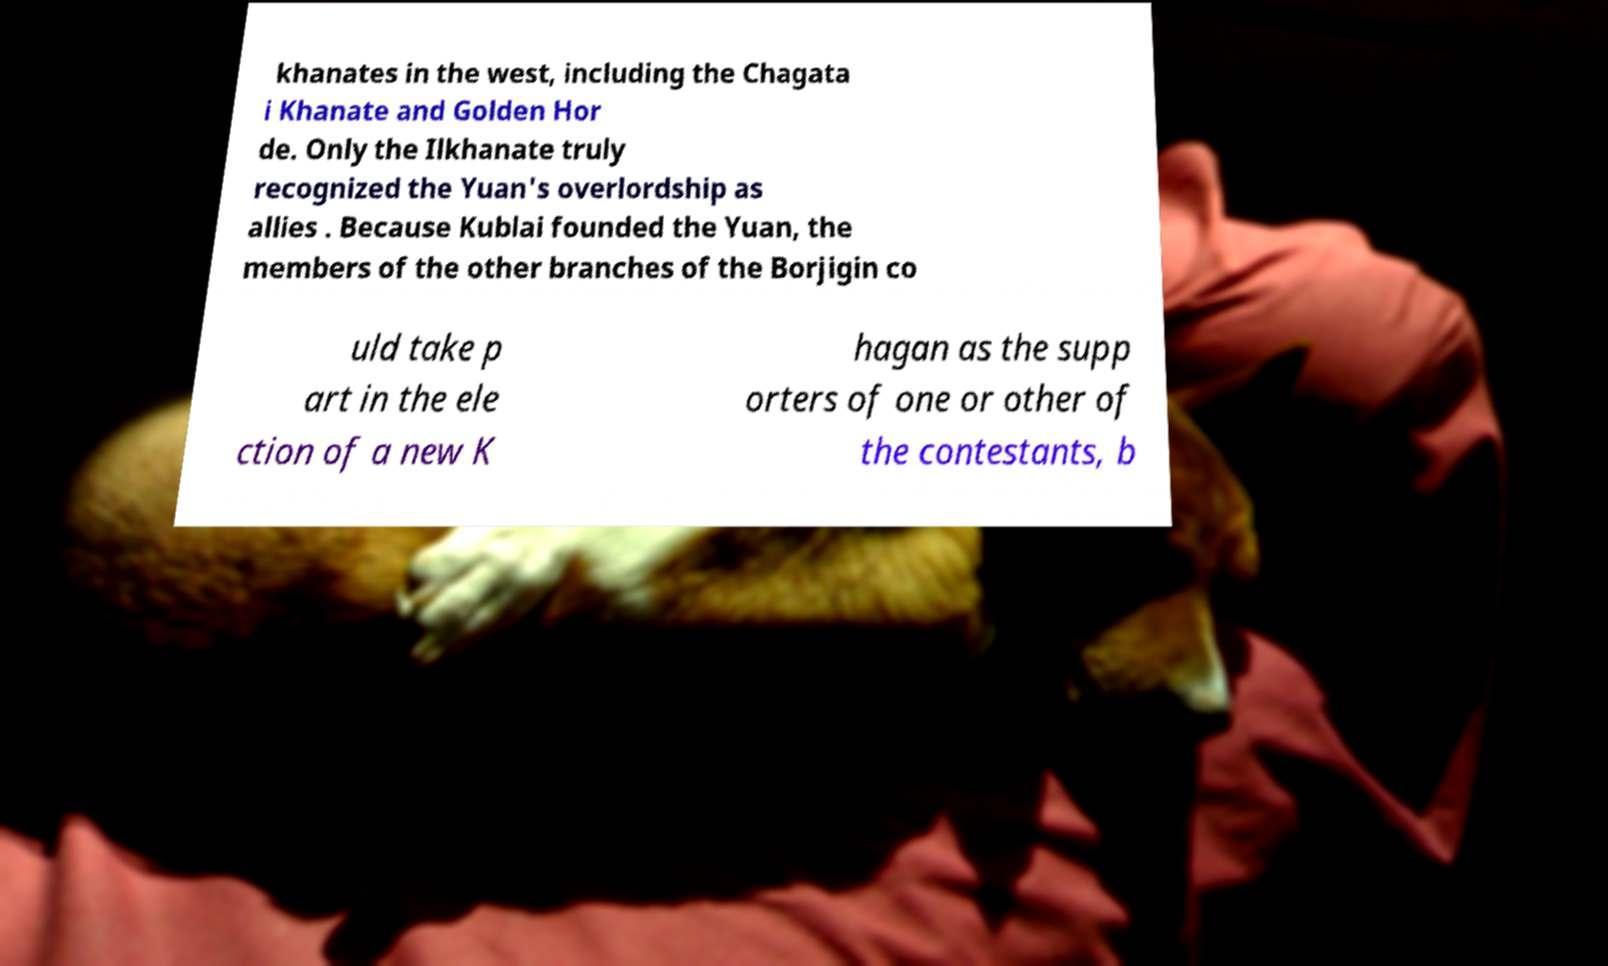What messages or text are displayed in this image? I need them in a readable, typed format. khanates in the west, including the Chagata i Khanate and Golden Hor de. Only the Ilkhanate truly recognized the Yuan's overlordship as allies . Because Kublai founded the Yuan, the members of the other branches of the Borjigin co uld take p art in the ele ction of a new K hagan as the supp orters of one or other of the contestants, b 